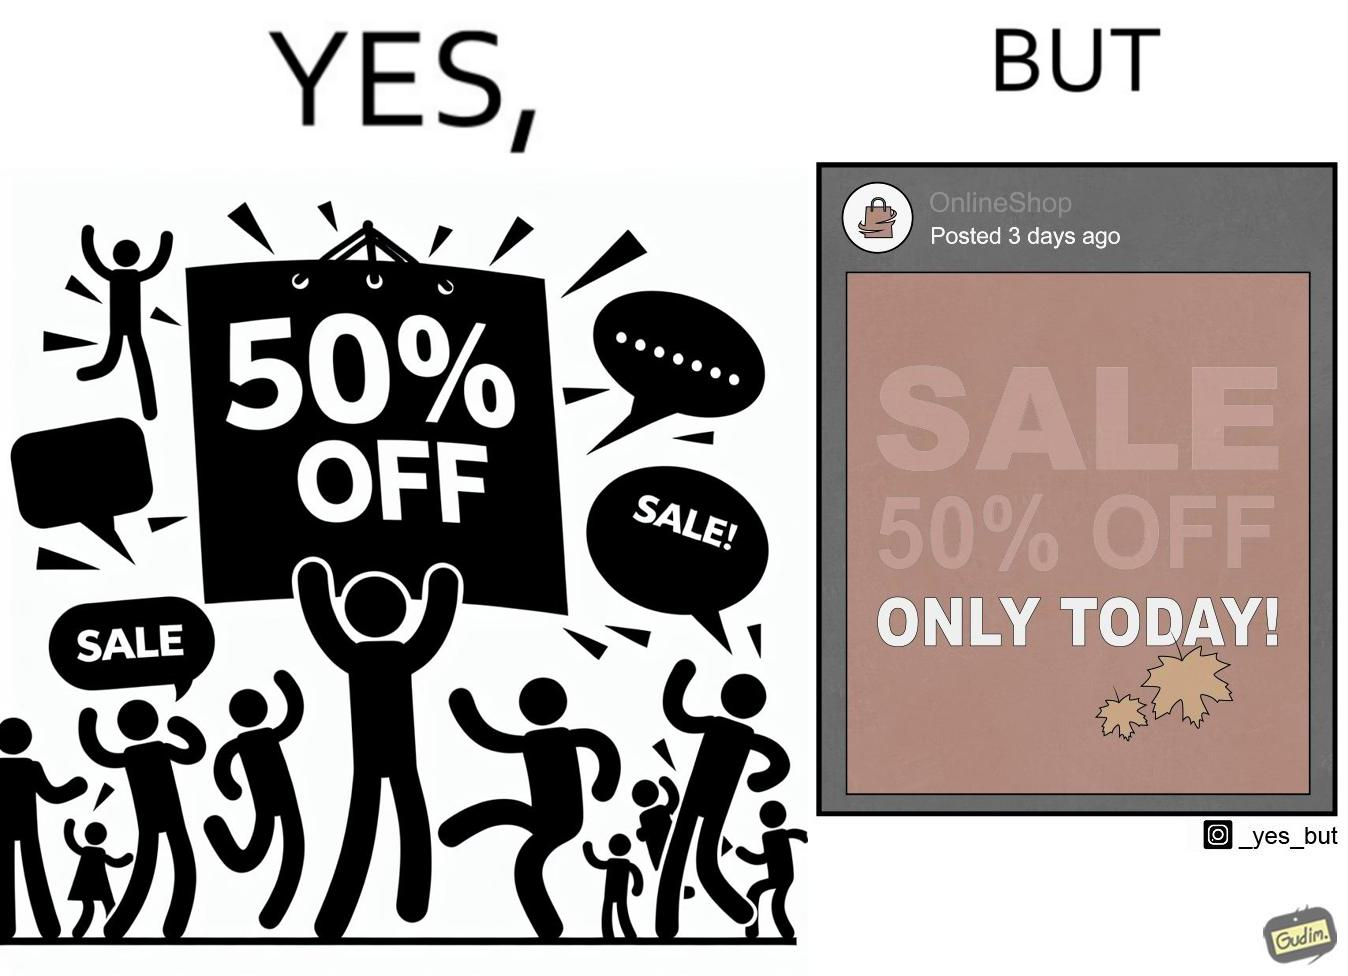Is this a satirical image? Yes, this image is satirical. 